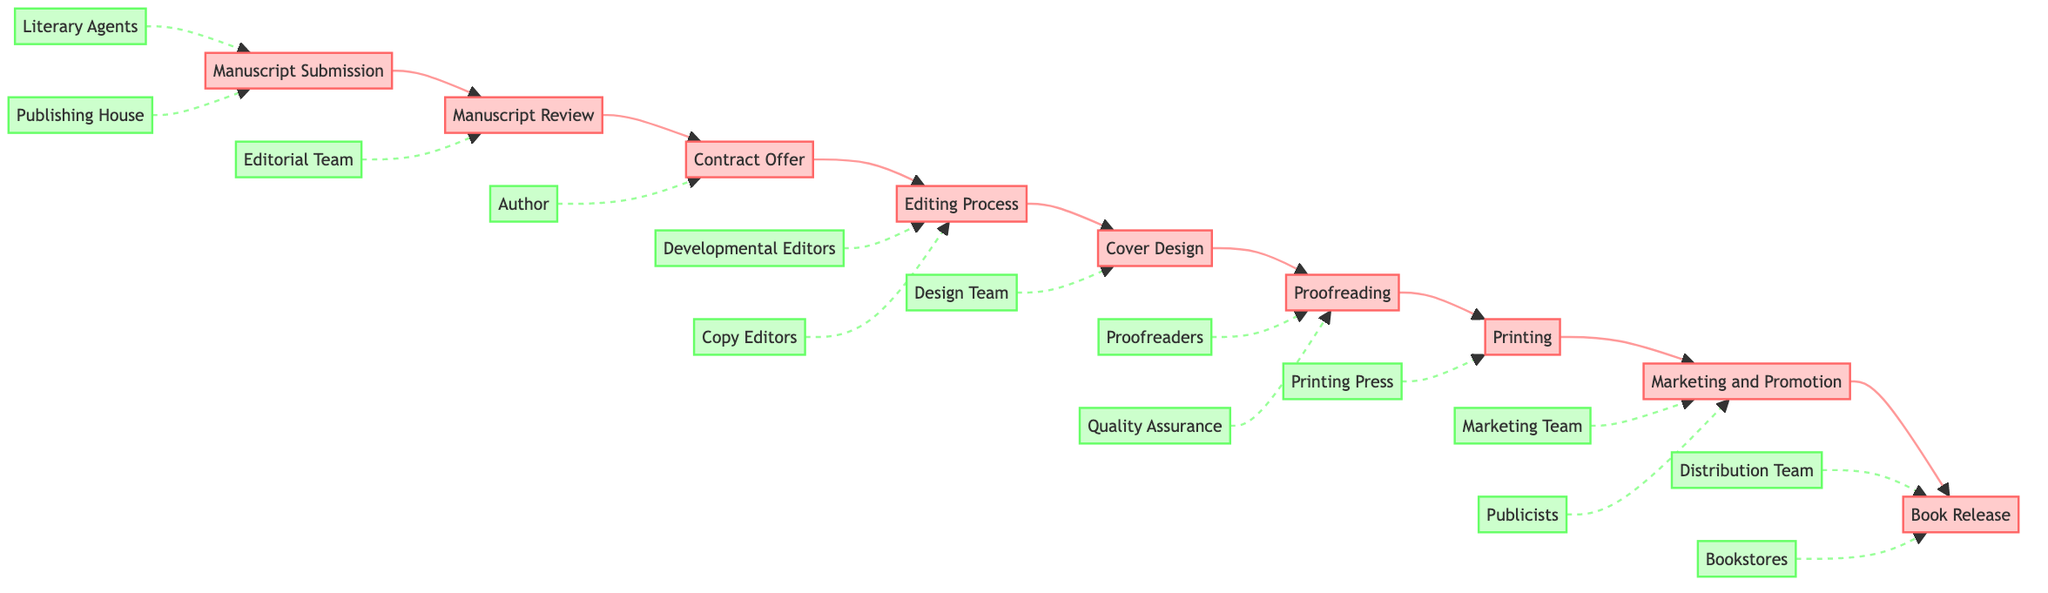what is the first step in the publishing process? The first step is indicated in the diagram as "Manuscript Submission."
Answer: Manuscript Submission how many steps are there in total in the publishing process? By counting each labeled step in the diagram, we find that there are 9 distinct steps.
Answer: 9 which entity is associated with the "Contract Offer" step? The entity linked to the "Contract Offer" step is the "Publishing House." This is indicated by the connection in the diagram.
Answer: Publishing House what happens after the "Cover Design" step? After "Cover Design," the next step in the flowchart is "Proofreading," which is directly following it.
Answer: Proofreading how many entities are involved in the "Editing Process" step? Under "Editing Process," there are two entities listed: "Developmental Editors" and "Copy Editors." Therefore, the total is 2.
Answer: 2 which steps involve the "Author" entity? The Author is involved in the steps "Contract Offer," "Cover Design," and "Marketing and Promotion," as indicated by the connections shown in the diagram.
Answer: Contract Offer, Cover Design, Marketing and Promotion what is the last step before the "Book Release"? The step immediately preceding "Book Release" is "Marketing and Promotion," which is the final preparation stage before release.
Answer: Marketing and Promotion which two roles are part of the "Proofreading" process? The roles involved in the "Proofreading" process, as depicted in the diagram, are "Proofreaders" and "Quality Assurance."
Answer: Proofreaders, Quality Assurance how is the "Editing Process" related to the "Manuscript Review"? The "Editing Process" follows the "Manuscript Review" step, forming a direct sequential connection in the flow of the diagram.
Answer: Sequential connection what is the purpose of the "Marketing and Promotion" step? The purpose of the "Marketing and Promotion" step is to conduct promotional activities and marketing campaigns, as described in the diagram.
Answer: Promotional activities and marketing campaigns 